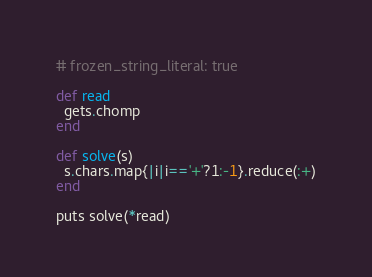Convert code to text. <code><loc_0><loc_0><loc_500><loc_500><_Ruby_># frozen_string_literal: true

def read
  gets.chomp
end

def solve(s)
  s.chars.map{|i|i=='+'?1:-1}.reduce(:+)
end

puts solve(*read)
</code> 